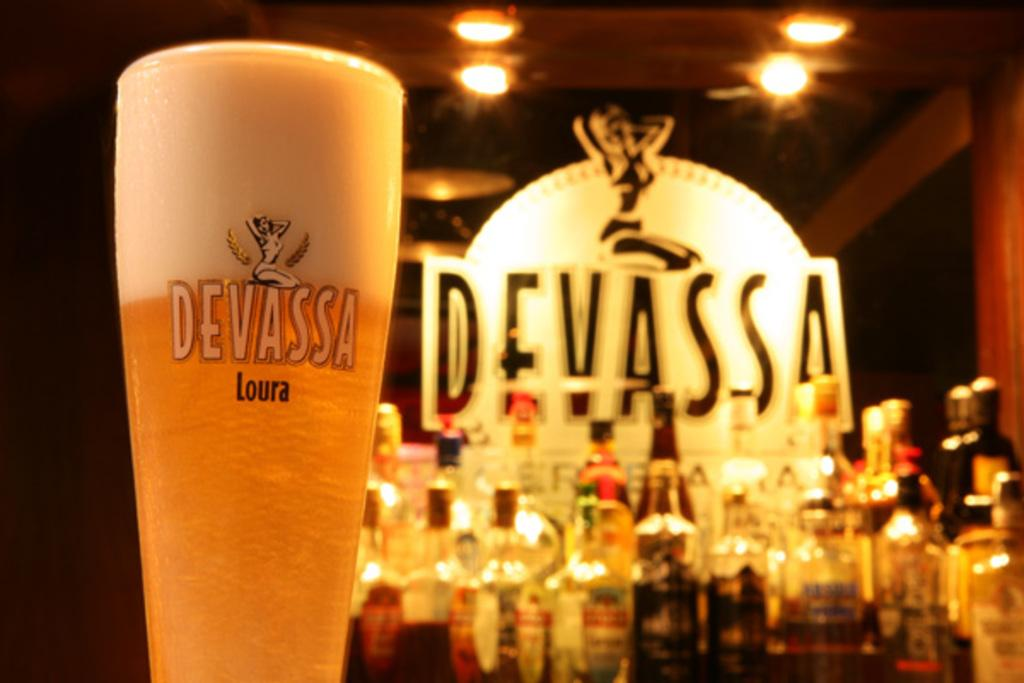<image>
Write a terse but informative summary of the picture. A glass with Devassa on it is filled with beer. 